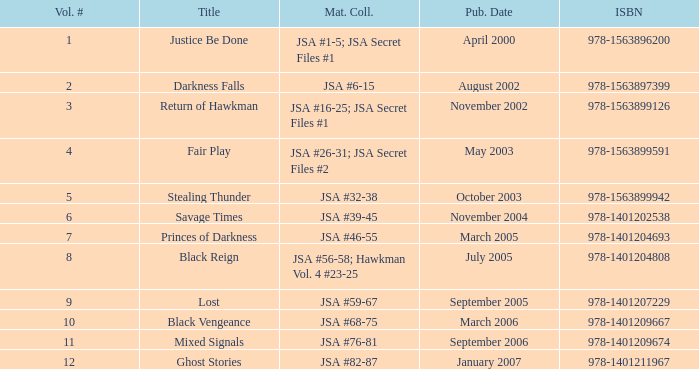How many Volume Numbers have the title of Darkness Falls? 2.0. 